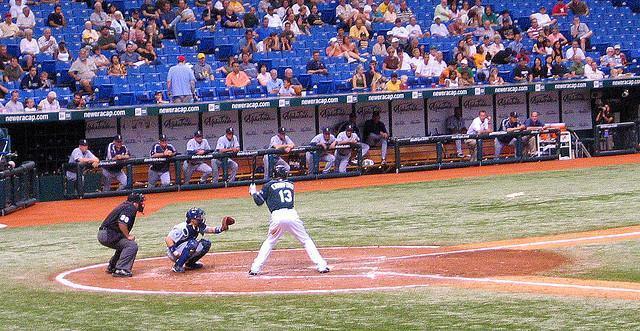How many people are there?
Give a very brief answer. 4. How many chairs are there?
Give a very brief answer. 1. 